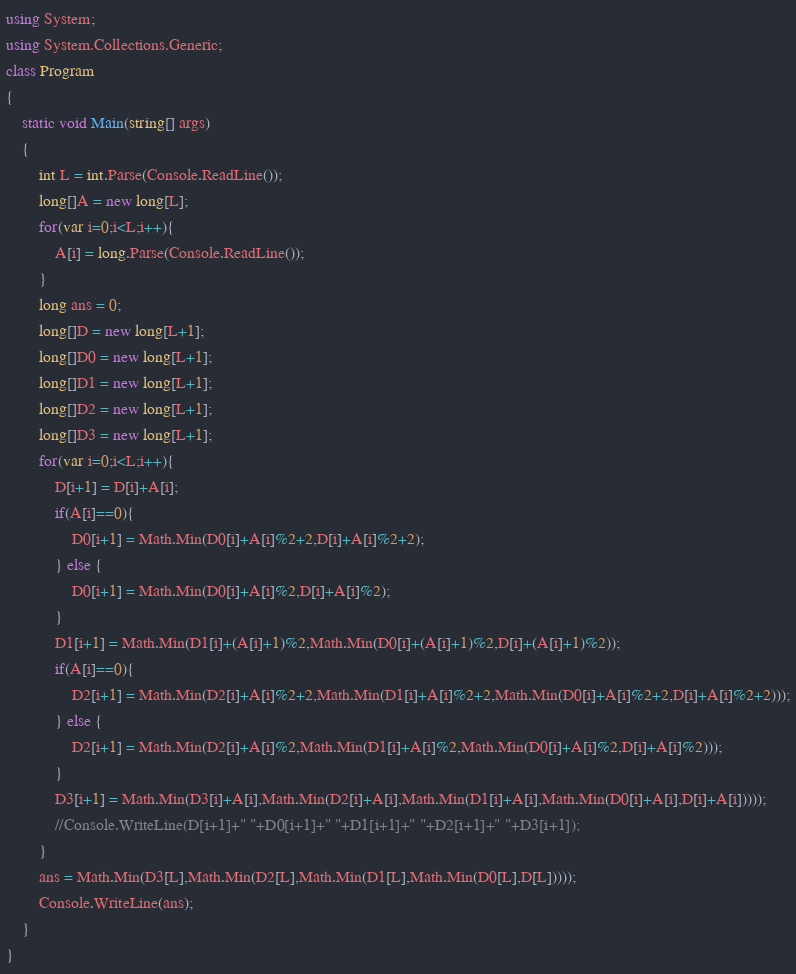<code> <loc_0><loc_0><loc_500><loc_500><_C#_>using System;
using System.Collections.Generic;
class Program
{
	static void Main(string[] args)
	{
		int L = int.Parse(Console.ReadLine());
		long[]A = new long[L];
		for(var i=0;i<L;i++){
			A[i] = long.Parse(Console.ReadLine());
		}
		long ans = 0;
		long[]D = new long[L+1];
		long[]D0 = new long[L+1];
		long[]D1 = new long[L+1];
		long[]D2 = new long[L+1];
		long[]D3 = new long[L+1];
		for(var i=0;i<L;i++){
			D[i+1] = D[i]+A[i];
			if(A[i]==0){
				D0[i+1] = Math.Min(D0[i]+A[i]%2+2,D[i]+A[i]%2+2);
			} else {
				D0[i+1] = Math.Min(D0[i]+A[i]%2,D[i]+A[i]%2);
			}
			D1[i+1] = Math.Min(D1[i]+(A[i]+1)%2,Math.Min(D0[i]+(A[i]+1)%2,D[i]+(A[i]+1)%2));
			if(A[i]==0){
				D2[i+1] = Math.Min(D2[i]+A[i]%2+2,Math.Min(D1[i]+A[i]%2+2,Math.Min(D0[i]+A[i]%2+2,D[i]+A[i]%2+2)));
			} else {
				D2[i+1] = Math.Min(D2[i]+A[i]%2,Math.Min(D1[i]+A[i]%2,Math.Min(D0[i]+A[i]%2,D[i]+A[i]%2)));
			}
			D3[i+1] = Math.Min(D3[i]+A[i],Math.Min(D2[i]+A[i],Math.Min(D1[i]+A[i],Math.Min(D0[i]+A[i],D[i]+A[i]))));
			//Console.WriteLine(D[i+1]+" "+D0[i+1]+" "+D1[i+1]+" "+D2[i+1]+" "+D3[i+1]);
		}
		ans = Math.Min(D3[L],Math.Min(D2[L],Math.Min(D1[L],Math.Min(D0[L],D[L]))));
		Console.WriteLine(ans);
	}
}</code> 